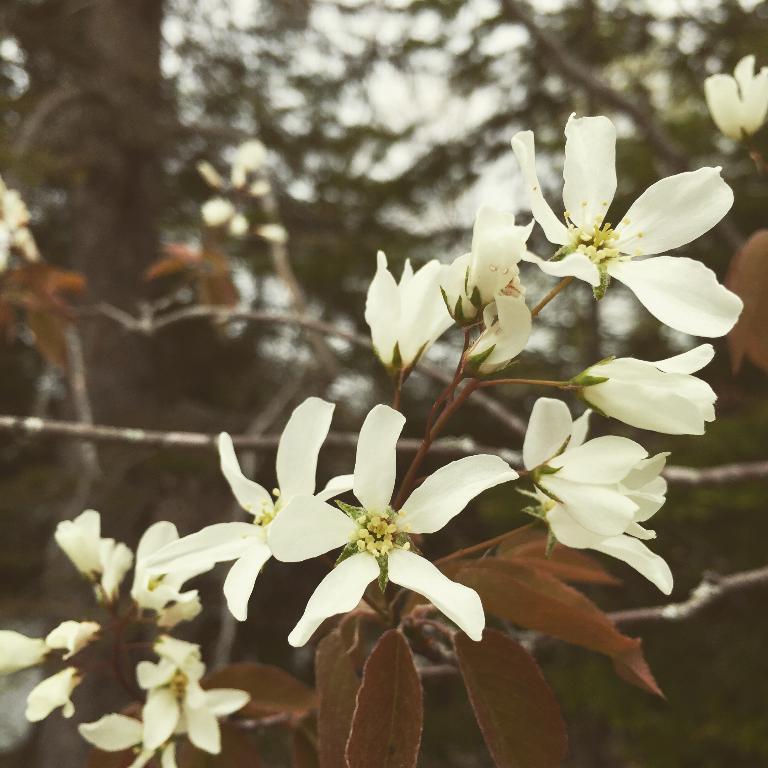Please provide a concise description of this image. In this picture I can see branches with leaves and white flowers, and in the background there are trees. 